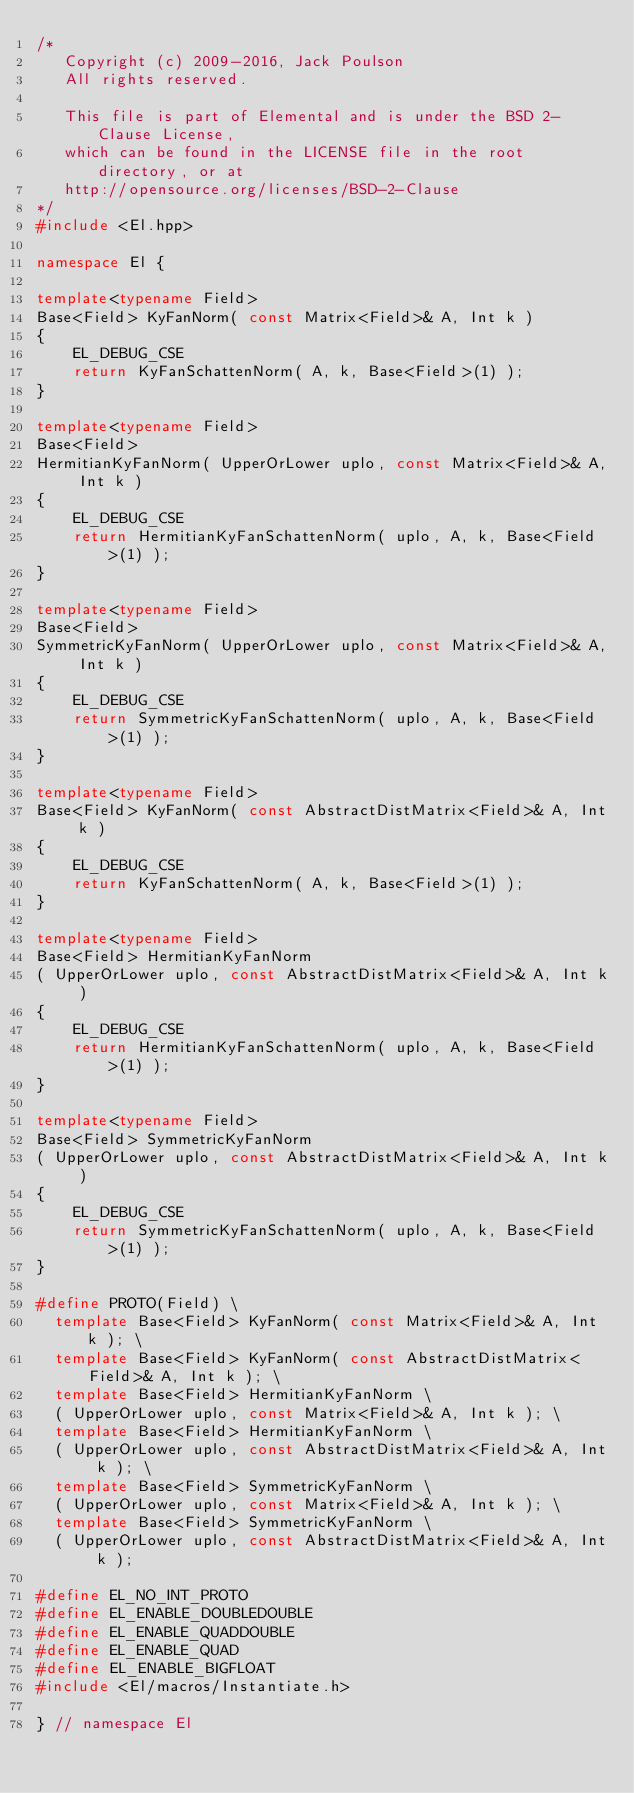<code> <loc_0><loc_0><loc_500><loc_500><_C++_>/*
   Copyright (c) 2009-2016, Jack Poulson
   All rights reserved.

   This file is part of Elemental and is under the BSD 2-Clause License,
   which can be found in the LICENSE file in the root directory, or at
   http://opensource.org/licenses/BSD-2-Clause
*/
#include <El.hpp>

namespace El {

template<typename Field>
Base<Field> KyFanNorm( const Matrix<Field>& A, Int k )
{
    EL_DEBUG_CSE
    return KyFanSchattenNorm( A, k, Base<Field>(1) );
}

template<typename Field>
Base<Field>
HermitianKyFanNorm( UpperOrLower uplo, const Matrix<Field>& A, Int k )
{
    EL_DEBUG_CSE
    return HermitianKyFanSchattenNorm( uplo, A, k, Base<Field>(1) );
}

template<typename Field>
Base<Field>
SymmetricKyFanNorm( UpperOrLower uplo, const Matrix<Field>& A, Int k )
{
    EL_DEBUG_CSE
    return SymmetricKyFanSchattenNorm( uplo, A, k, Base<Field>(1) );
}

template<typename Field>
Base<Field> KyFanNorm( const AbstractDistMatrix<Field>& A, Int k )
{
    EL_DEBUG_CSE
    return KyFanSchattenNorm( A, k, Base<Field>(1) );
}

template<typename Field>
Base<Field> HermitianKyFanNorm
( UpperOrLower uplo, const AbstractDistMatrix<Field>& A, Int k )
{
    EL_DEBUG_CSE
    return HermitianKyFanSchattenNorm( uplo, A, k, Base<Field>(1) );
}

template<typename Field>
Base<Field> SymmetricKyFanNorm
( UpperOrLower uplo, const AbstractDistMatrix<Field>& A, Int k )
{
    EL_DEBUG_CSE
    return SymmetricKyFanSchattenNorm( uplo, A, k, Base<Field>(1) );
}

#define PROTO(Field) \
  template Base<Field> KyFanNorm( const Matrix<Field>& A, Int k ); \
  template Base<Field> KyFanNorm( const AbstractDistMatrix<Field>& A, Int k ); \
  template Base<Field> HermitianKyFanNorm \
  ( UpperOrLower uplo, const Matrix<Field>& A, Int k ); \
  template Base<Field> HermitianKyFanNorm \
  ( UpperOrLower uplo, const AbstractDistMatrix<Field>& A, Int k ); \
  template Base<Field> SymmetricKyFanNorm \
  ( UpperOrLower uplo, const Matrix<Field>& A, Int k ); \
  template Base<Field> SymmetricKyFanNorm \
  ( UpperOrLower uplo, const AbstractDistMatrix<Field>& A, Int k );

#define EL_NO_INT_PROTO
#define EL_ENABLE_DOUBLEDOUBLE
#define EL_ENABLE_QUADDOUBLE
#define EL_ENABLE_QUAD
#define EL_ENABLE_BIGFLOAT
#include <El/macros/Instantiate.h>

} // namespace El
</code> 